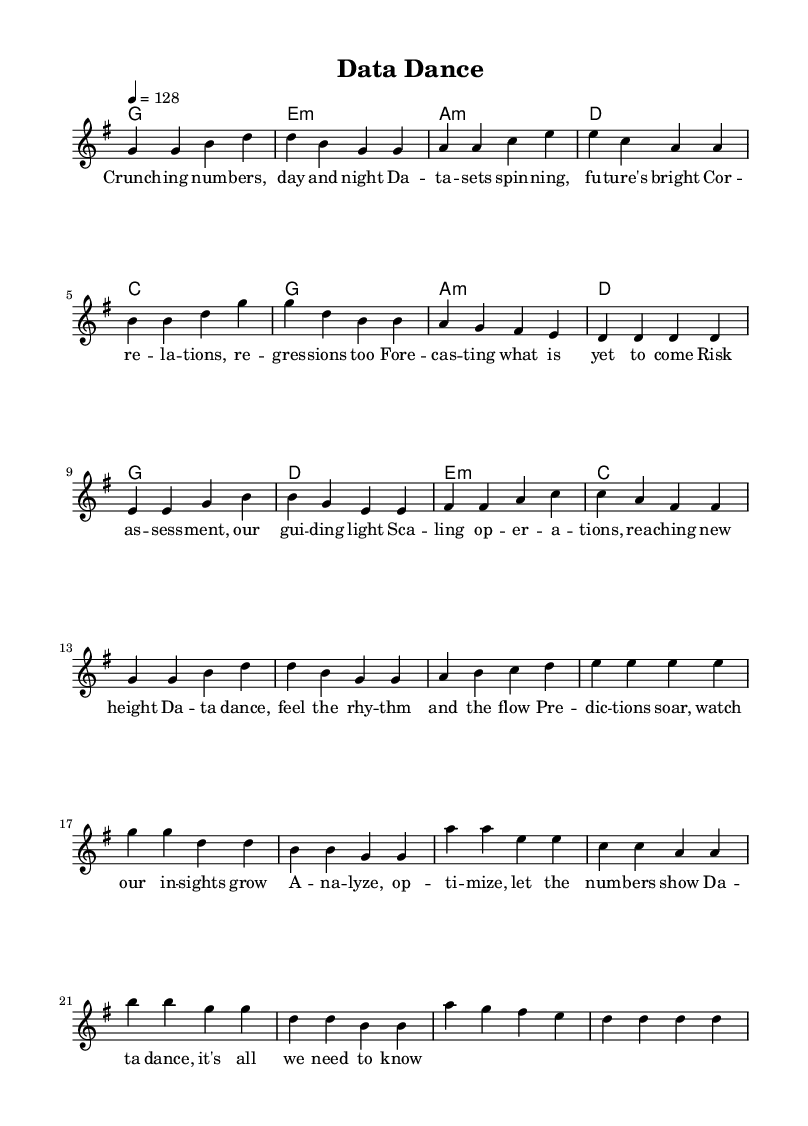What is the key signature of this music? The key signature is indicated at the beginning of the staff, and it shows one sharp, which corresponds to G major.
Answer: G major What is the time signature of this piece? The time signature appears at the start of the score, represented as 4/4, meaning there are four beats in each measure.
Answer: 4/4 What is the tempo of the piece? The tempo marking is provided at the beginning and indicates a speed of 128 beats per minute, set with a quarter note equals 128.
Answer: 128 How many sections are present in the music? By examining the musical structure, there are three sections identifiable: Verse, Pre-Chorus, and Chorus.
Answer: Three What is the primary theme of the lyrics? The lyrics focus on data analysis, forecasting, and the energetic process of 'dancing' through data, which reflects the theme of data analytics.
Answer: Data analysis What is the last chord in the score? The last chord is denoted in the harmonies section, and it shows a D major chord at the end of the score.
Answer: D Which part of the song features the line "Risk assessment, our guiding light"? This line is part of the pre-chorus section as indicated in the structure and lyrics alignment of the sheet music.
Answer: Pre-Chorus 